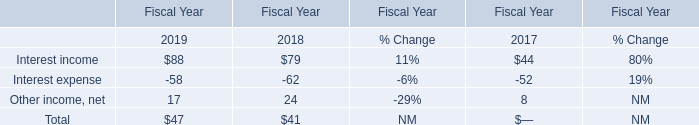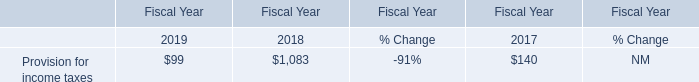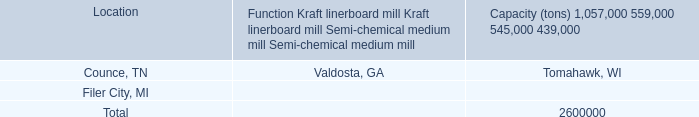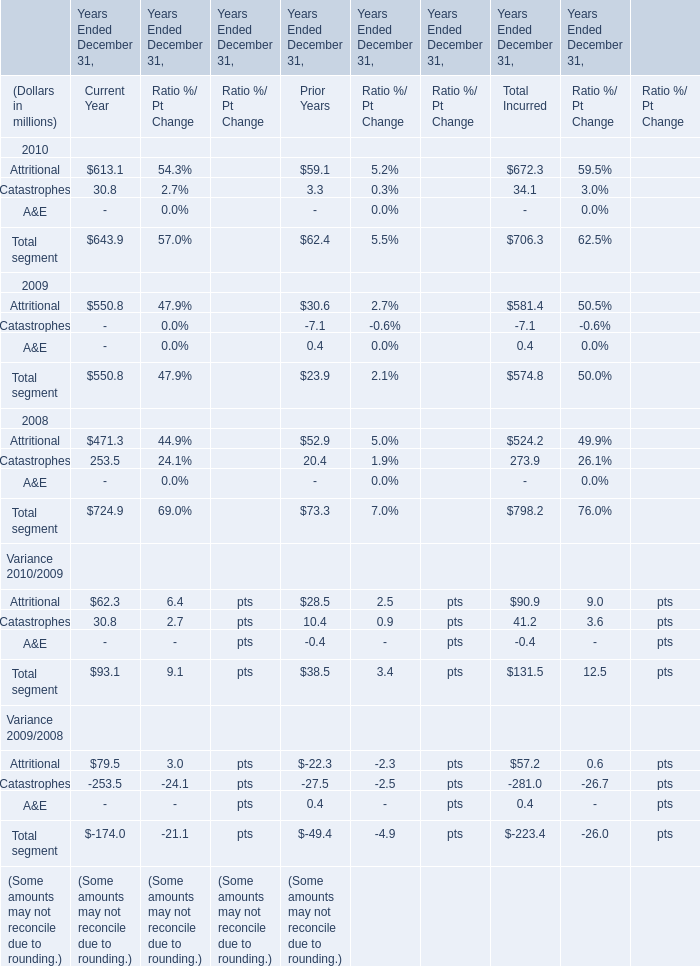Does the average value of attritional in 2010 for current year greater than that in 2009? 
Answer: yes. 